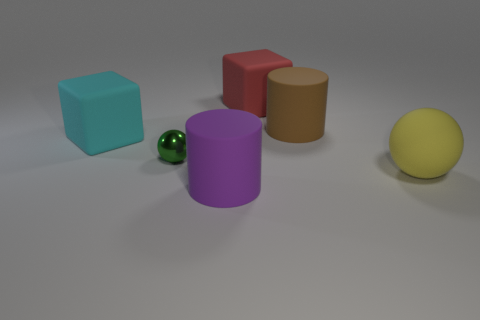There is a cylinder that is in front of the large cyan thing; what color is it?
Keep it short and to the point. Purple. How many small green things are right of the large matte block on the left side of the tiny green shiny sphere?
Your answer should be compact. 1. There is a brown matte cylinder; is its size the same as the ball that is to the left of the large matte sphere?
Your response must be concise. No. Are there any yellow rubber blocks of the same size as the cyan matte block?
Make the answer very short. No. What number of objects are big cylinders or large cyan matte cubes?
Provide a short and direct response. 3. Does the cube right of the metallic thing have the same size as the matte block that is to the left of the metal object?
Your answer should be very brief. Yes. Are there any tiny things of the same shape as the large red thing?
Offer a very short reply. No. Is the number of green metal objects that are left of the cyan matte cube less than the number of tiny red cubes?
Ensure brevity in your answer.  No. Is the shape of the large red matte thing the same as the large purple rubber object?
Your answer should be compact. No. There is a cube that is on the right side of the green sphere; what size is it?
Keep it short and to the point. Large. 